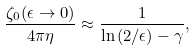<formula> <loc_0><loc_0><loc_500><loc_500>\frac { \zeta _ { 0 } ( \epsilon \rightarrow 0 ) } { 4 \pi \eta } \approx \frac { 1 } { \ln { ( 2 / \epsilon ) } - \gamma } ,</formula> 